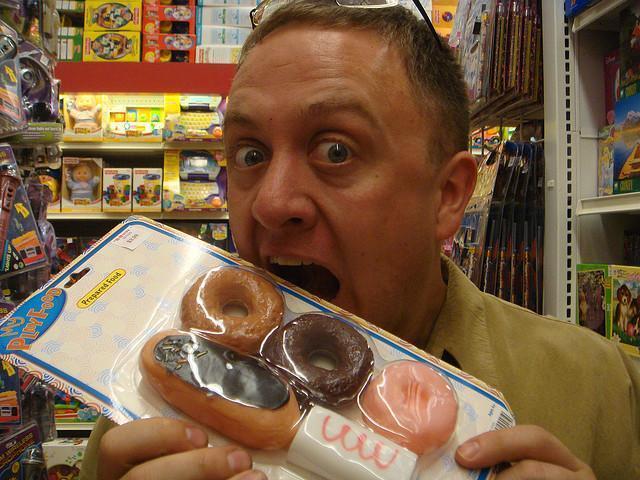How many doughnuts are there?
Give a very brief answer. 5. How many donuts can be seen?
Give a very brief answer. 4. 